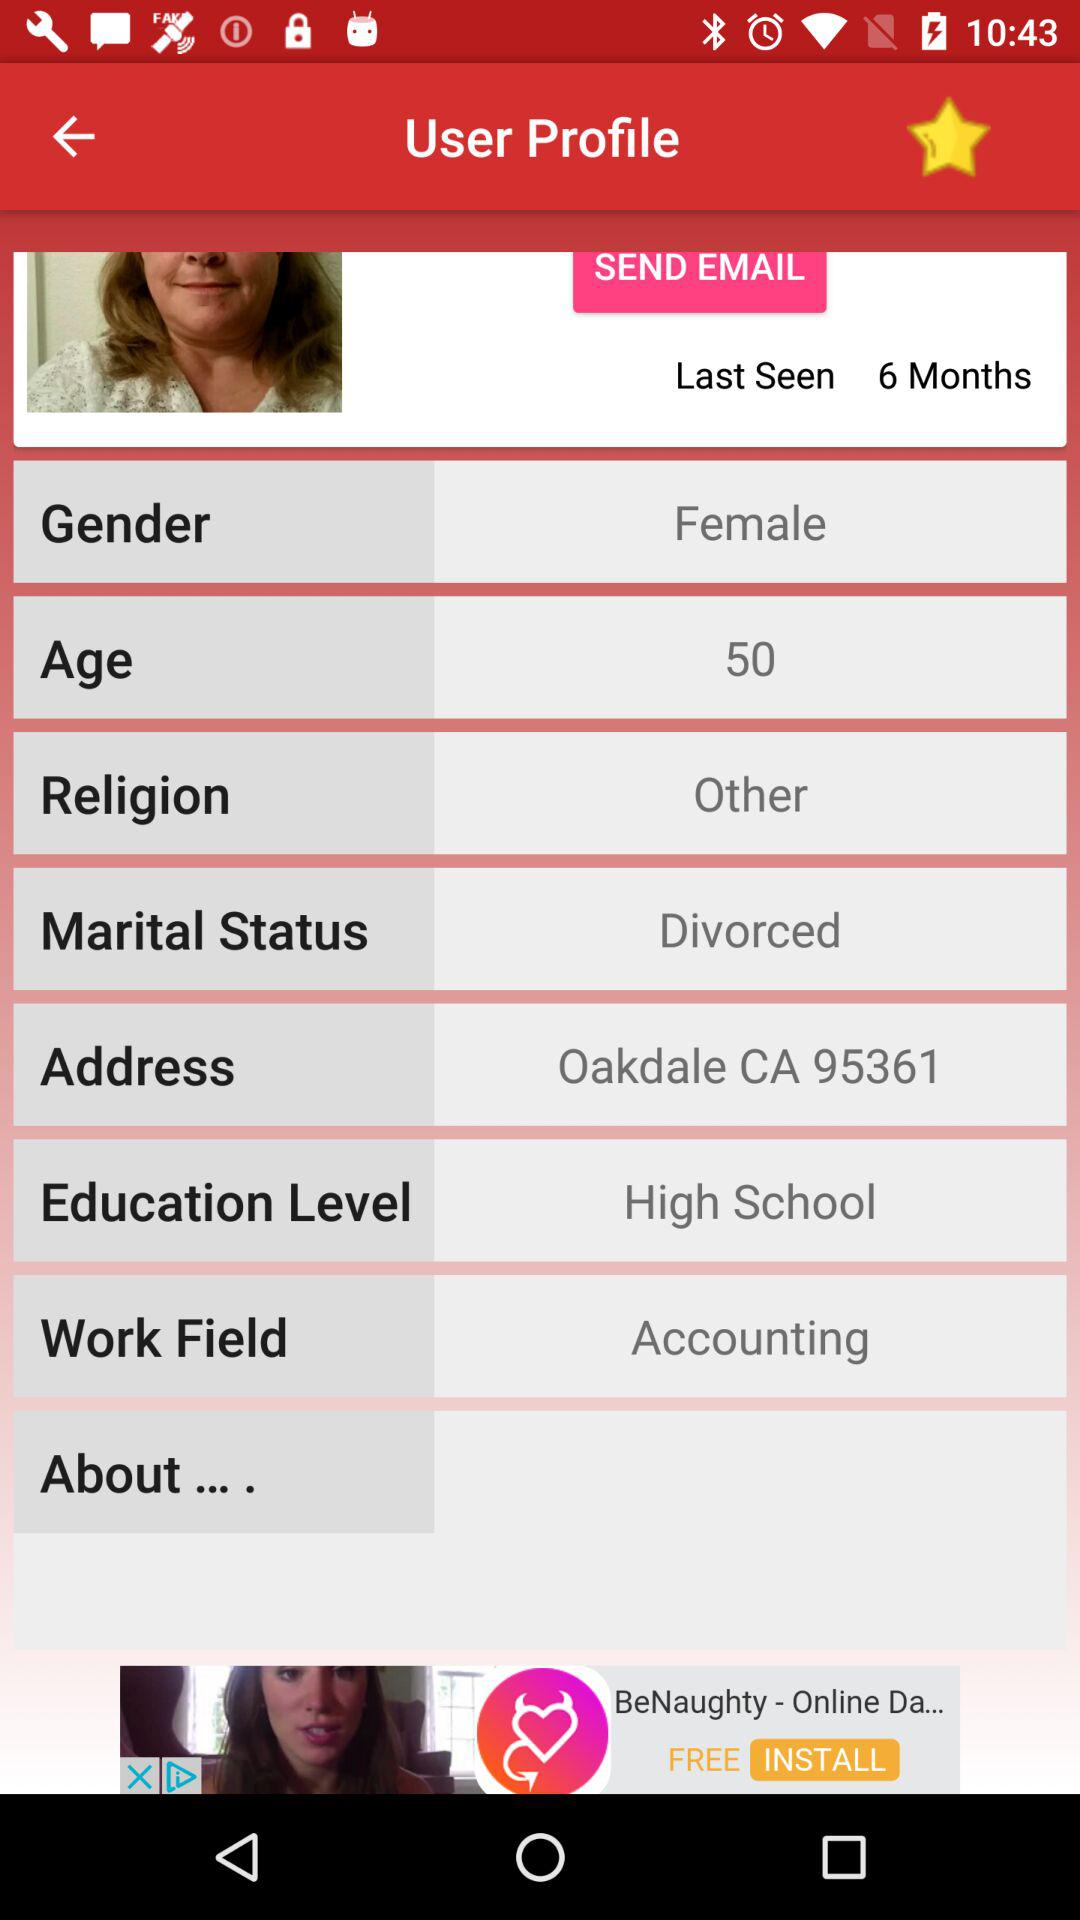What is the field of work? The field of work is accounting. 